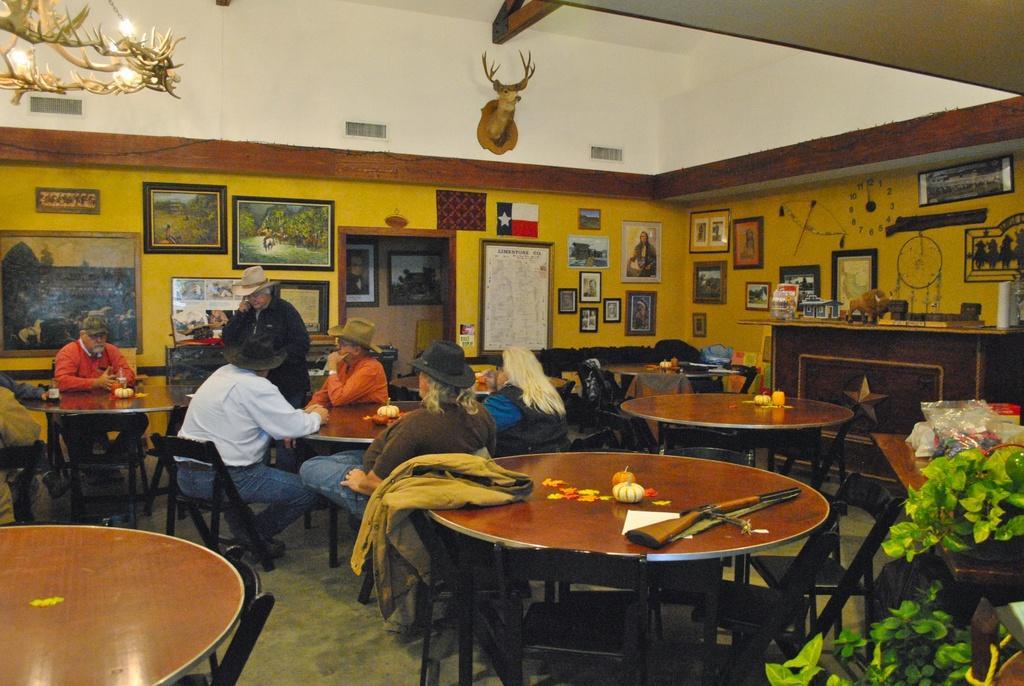How would you summarize this image in a sentence or two? In this i can see a there are the tables kept on the floor and the right side i can see a plant and on the wall i can see a no of photo frame attached to the wall and there is a group of persons sitting around the table. And there is a chandelier on the left side. 